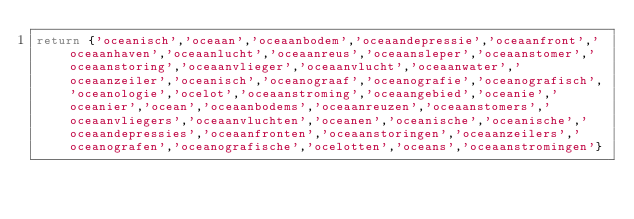<code> <loc_0><loc_0><loc_500><loc_500><_Lua_>return {'oceanisch','oceaan','oceaanbodem','oceaandepressie','oceaanfront','oceaanhaven','oceaanlucht','oceaanreus','oceaansleper','oceaanstomer','oceaanstoring','oceaanvlieger','oceaanvlucht','oceaanwater','oceaanzeiler','oceanisch','oceanograaf','oceanografie','oceanografisch','oceanologie','ocelot','oceaanstroming','oceaangebied','oceanie','oceanier','ocean','oceaanbodems','oceaanreuzen','oceaanstomers','oceaanvliegers','oceaanvluchten','oceanen','oceanische','oceanische','oceaandepressies','oceaanfronten','oceaanstoringen','oceaanzeilers','oceanografen','oceanografische','ocelotten','oceans','oceaanstromingen'}</code> 